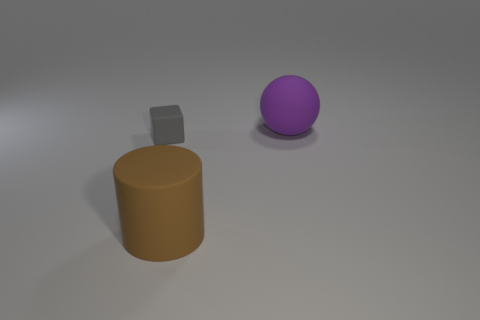Are there fewer gray blocks behind the purple ball than large balls?
Make the answer very short. Yes. What size is the sphere that is made of the same material as the brown cylinder?
Your response must be concise. Large. What material is the large thing that is behind the large matte thing in front of the rubber object behind the small gray matte thing made of?
Give a very brief answer. Rubber. Is the number of large matte objects less than the number of small gray blocks?
Give a very brief answer. No. Are the big purple thing and the small gray cube made of the same material?
Make the answer very short. Yes. What number of large objects are behind the thing in front of the small thing?
Provide a succinct answer. 1. What is the color of the rubber thing that is the same size as the purple matte sphere?
Keep it short and to the point. Brown. There is a big object behind the large brown matte object; what is it made of?
Keep it short and to the point. Rubber. There is a matte thing behind the cube; is it the same size as the big brown matte thing?
Make the answer very short. Yes. What shape is the big brown object?
Provide a succinct answer. Cylinder. 